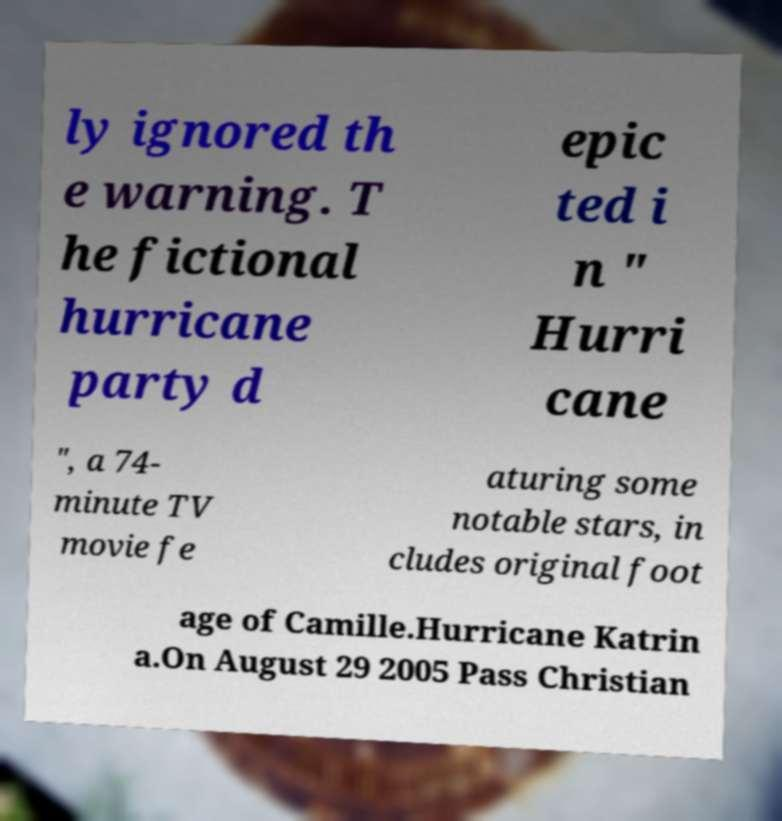Can you accurately transcribe the text from the provided image for me? ly ignored th e warning. T he fictional hurricane party d epic ted i n " Hurri cane ", a 74- minute TV movie fe aturing some notable stars, in cludes original foot age of Camille.Hurricane Katrin a.On August 29 2005 Pass Christian 